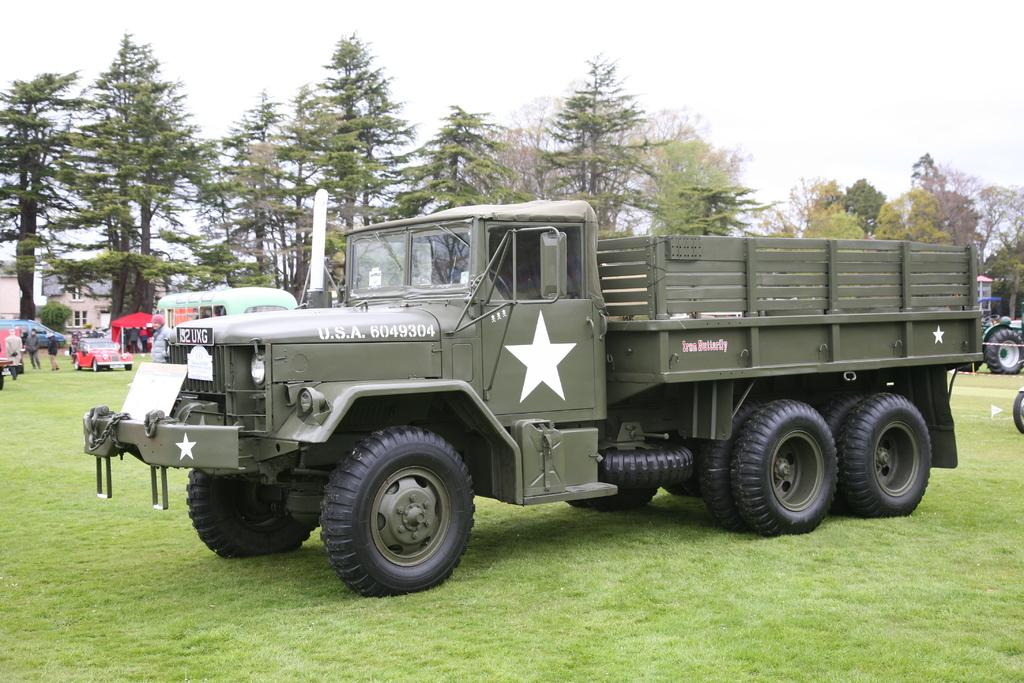What type of vehicle is located on the grassy land in the image? There is a truck on the grassy land in the image. What other vehicles can be seen in the background of the image? There is a car and a tempo in the background of the image. What else is visible in the background of the image? There are people and trees in the background of the image. What is visible at the top of the image? The sky is visible at the top of the image. What type of tray is being used by the crook in the image? There is no crook or tray present in the image. What is the engine of the truck in the image? The image does not provide information about the engine of the truck. 